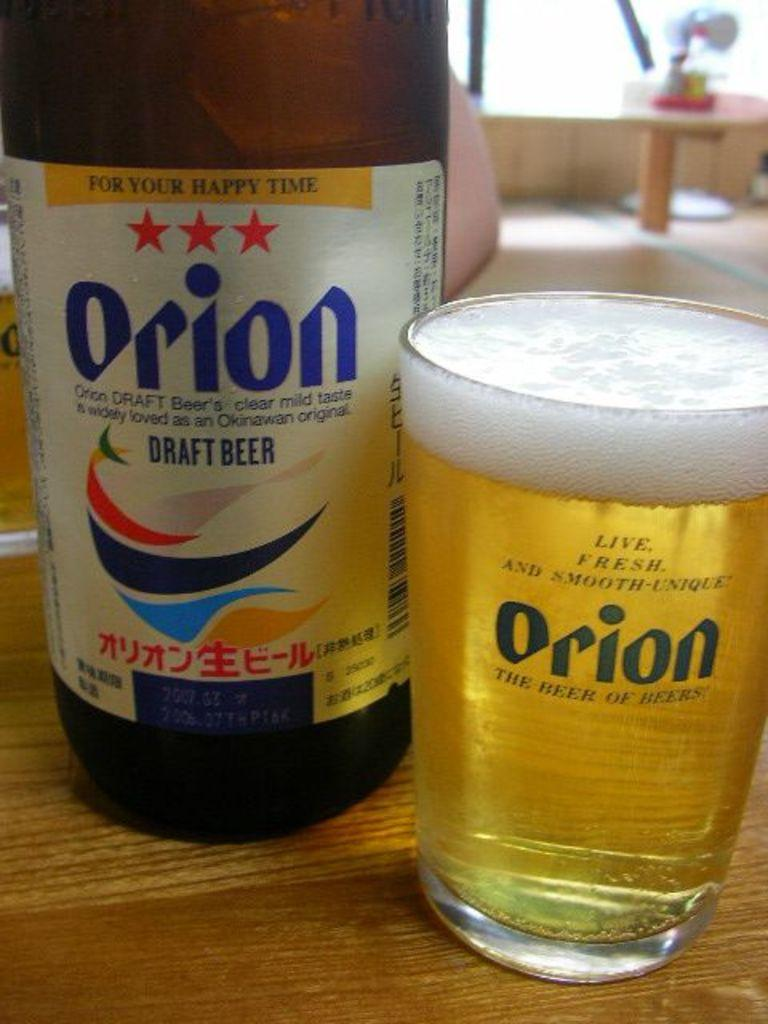What type of beverage is featured in the image? There is a beer bottle and a glass full of beer in the image. Where are the beer bottle and the glass located? Both the beer bottle and the glass are on a table. Can you describe the table setting in the image? The table setting includes a beer bottle and a glass full of beer. How many yams are present on the table in the image? There are no yams present on the table in the image. What historical event is depicted in the image? The image does not depict any historical event; it features a beer bottle and a glass full of beer on a table. 